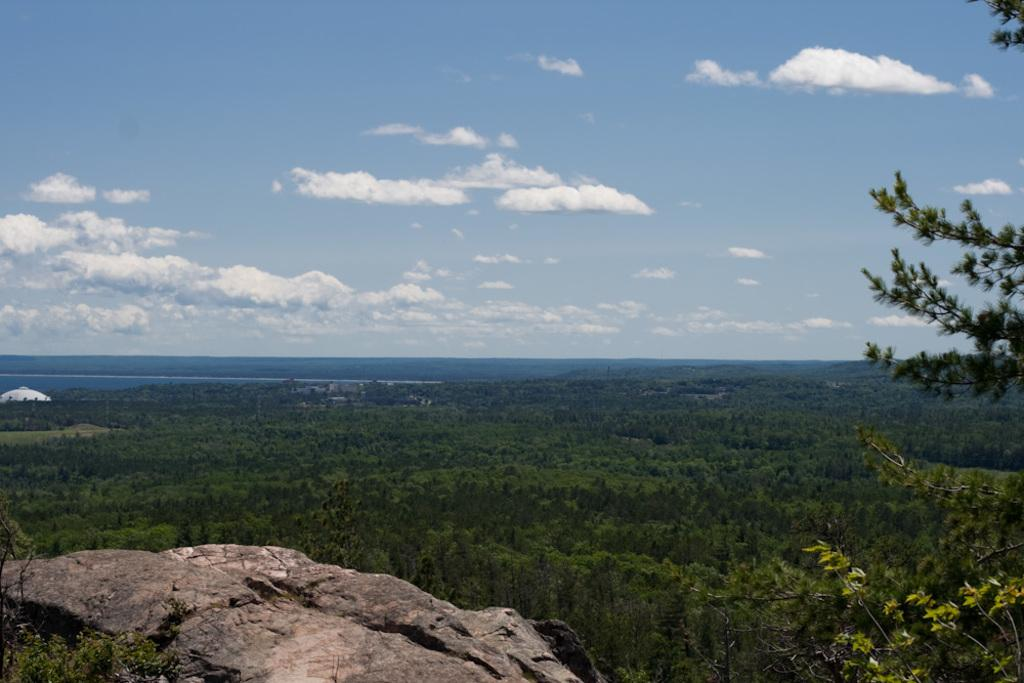What is located in the front of the image? There is a stone in the front of the image. What can be seen in the center of the image? There are trees in the center of the image. What is visible in the background of the image? Water is visible in the background of the image. How would you describe the sky in the image? The sky is cloudy in the image. Can you tell me what type of answer the stone is giving in the image? There is no indication in the image that the stone is providing an answer, as stones do not have the ability to communicate or answer questions. Is there a dog visible in the image? No, there is no dog present in the image. 